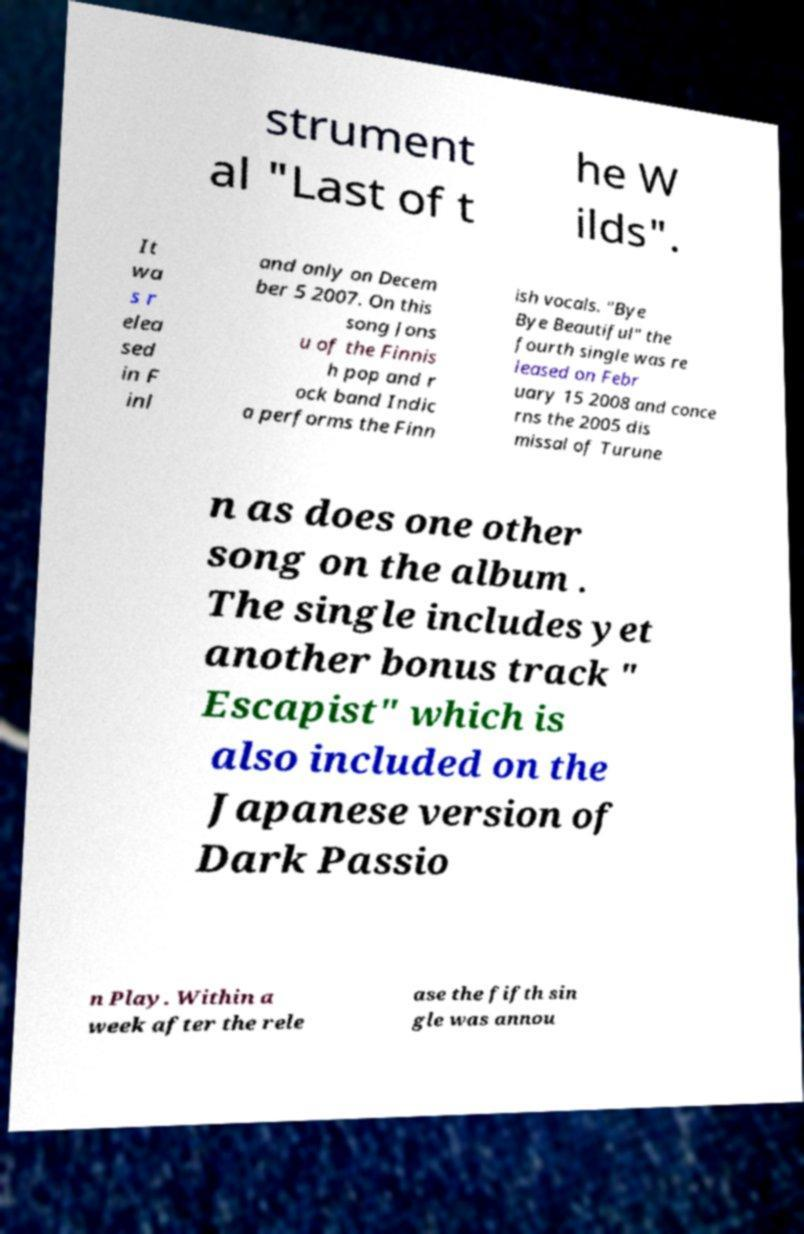Please read and relay the text visible in this image. What does it say? strument al "Last of t he W ilds". It wa s r elea sed in F inl and only on Decem ber 5 2007. On this song Jons u of the Finnis h pop and r ock band Indic a performs the Finn ish vocals. "Bye Bye Beautiful" the fourth single was re leased on Febr uary 15 2008 and conce rns the 2005 dis missal of Turune n as does one other song on the album . The single includes yet another bonus track " Escapist" which is also included on the Japanese version of Dark Passio n Play. Within a week after the rele ase the fifth sin gle was annou 